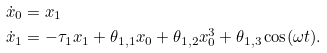<formula> <loc_0><loc_0><loc_500><loc_500>\dot { x } _ { 0 } & = x _ { 1 } \\ \dot { x } _ { 1 } & = - \tau _ { 1 } x _ { 1 } + \theta _ { 1 , 1 } x _ { 0 } + \theta _ { 1 , 2 } x _ { 0 } ^ { 3 } + \theta _ { 1 , 3 } \cos ( \omega t ) .</formula> 